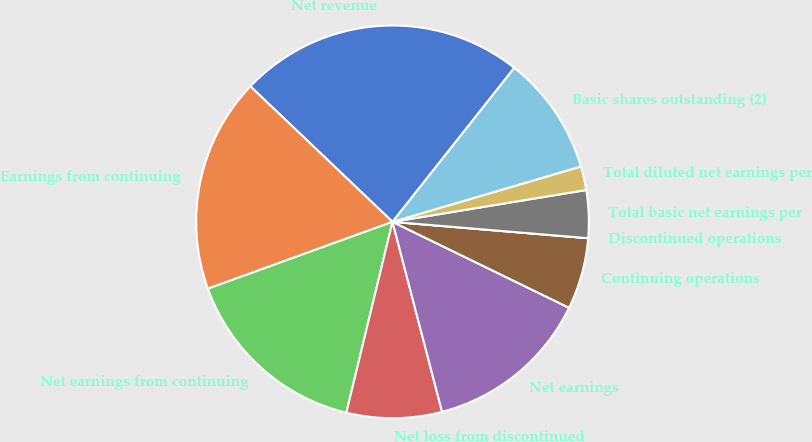<chart> <loc_0><loc_0><loc_500><loc_500><pie_chart><fcel>Net revenue<fcel>Earnings from continuing<fcel>Net earnings from continuing<fcel>Net loss from discontinued<fcel>Net earnings<fcel>Continuing operations<fcel>Discontinued operations<fcel>Total basic net earnings per<fcel>Total diluted net earnings per<fcel>Basic shares outstanding (2)<nl><fcel>23.53%<fcel>17.65%<fcel>15.69%<fcel>7.84%<fcel>13.73%<fcel>5.88%<fcel>0.0%<fcel>3.92%<fcel>1.96%<fcel>9.8%<nl></chart> 